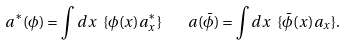<formula> <loc_0><loc_0><loc_500><loc_500>a ^ { \ast } ( \phi ) = \int d x \ \{ \phi ( x ) a ^ { \ast } _ { x } \} \quad a ( \bar { \phi } ) = \int d x \ \{ \bar { \phi } ( x ) a _ { x } \} .</formula> 